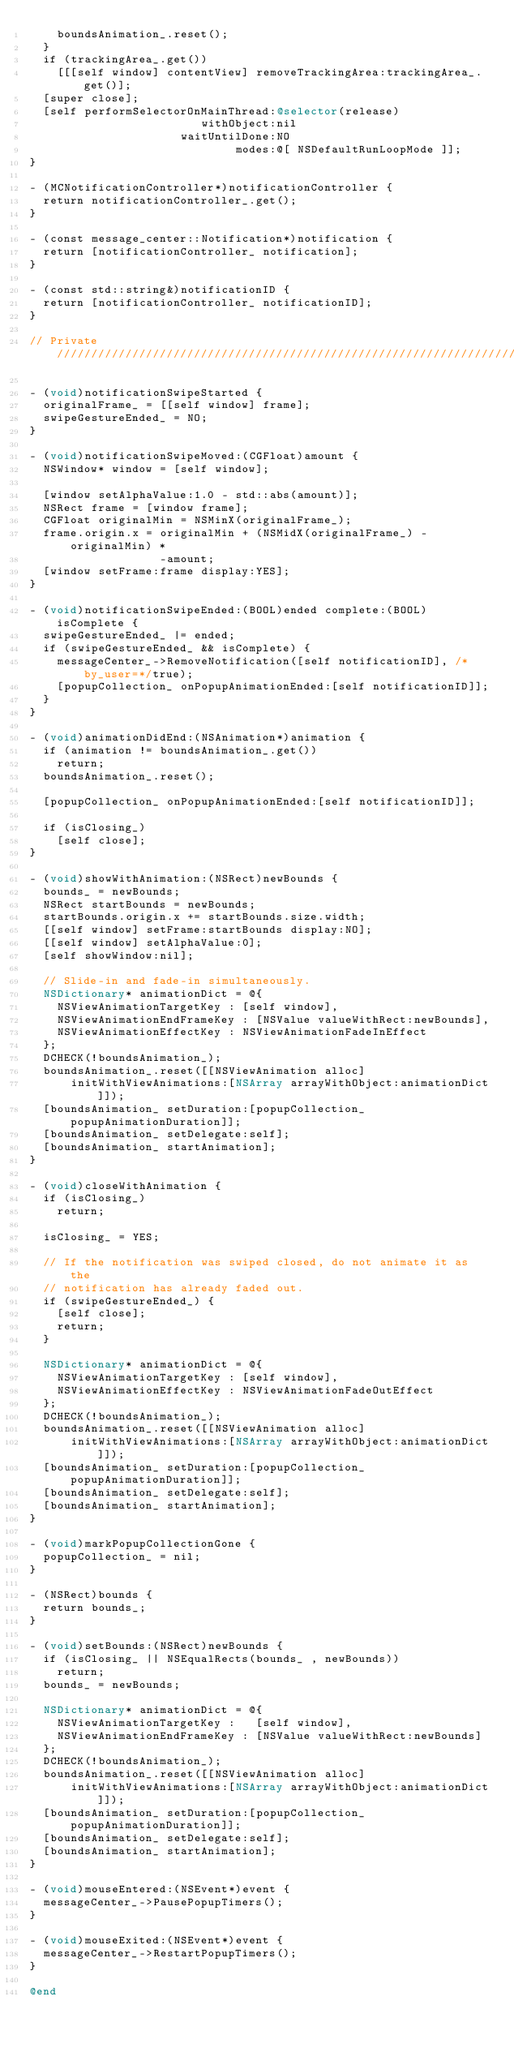Convert code to text. <code><loc_0><loc_0><loc_500><loc_500><_ObjectiveC_>    boundsAnimation_.reset();
  }
  if (trackingArea_.get())
    [[[self window] contentView] removeTrackingArea:trackingArea_.get()];
  [super close];
  [self performSelectorOnMainThread:@selector(release)
                         withObject:nil
                      waitUntilDone:NO
                              modes:@[ NSDefaultRunLoopMode ]];
}

- (MCNotificationController*)notificationController {
  return notificationController_.get();
}

- (const message_center::Notification*)notification {
  return [notificationController_ notification];
}

- (const std::string&)notificationID {
  return [notificationController_ notificationID];
}

// Private /////////////////////////////////////////////////////////////////////

- (void)notificationSwipeStarted {
  originalFrame_ = [[self window] frame];
  swipeGestureEnded_ = NO;
}

- (void)notificationSwipeMoved:(CGFloat)amount {
  NSWindow* window = [self window];

  [window setAlphaValue:1.0 - std::abs(amount)];
  NSRect frame = [window frame];
  CGFloat originalMin = NSMinX(originalFrame_);
  frame.origin.x = originalMin + (NSMidX(originalFrame_) - originalMin) *
                   -amount;
  [window setFrame:frame display:YES];
}

- (void)notificationSwipeEnded:(BOOL)ended complete:(BOOL)isComplete {
  swipeGestureEnded_ |= ended;
  if (swipeGestureEnded_ && isComplete) {
    messageCenter_->RemoveNotification([self notificationID], /*by_user=*/true);
    [popupCollection_ onPopupAnimationEnded:[self notificationID]];
  }
}

- (void)animationDidEnd:(NSAnimation*)animation {
  if (animation != boundsAnimation_.get())
    return;
  boundsAnimation_.reset();

  [popupCollection_ onPopupAnimationEnded:[self notificationID]];

  if (isClosing_)
    [self close];
}

- (void)showWithAnimation:(NSRect)newBounds {
  bounds_ = newBounds;
  NSRect startBounds = newBounds;
  startBounds.origin.x += startBounds.size.width;
  [[self window] setFrame:startBounds display:NO];
  [[self window] setAlphaValue:0];
  [self showWindow:nil];

  // Slide-in and fade-in simultaneously.
  NSDictionary* animationDict = @{
    NSViewAnimationTargetKey : [self window],
    NSViewAnimationEndFrameKey : [NSValue valueWithRect:newBounds],
    NSViewAnimationEffectKey : NSViewAnimationFadeInEffect
  };
  DCHECK(!boundsAnimation_);
  boundsAnimation_.reset([[NSViewAnimation alloc]
      initWithViewAnimations:[NSArray arrayWithObject:animationDict]]);
  [boundsAnimation_ setDuration:[popupCollection_ popupAnimationDuration]];
  [boundsAnimation_ setDelegate:self];
  [boundsAnimation_ startAnimation];
}

- (void)closeWithAnimation {
  if (isClosing_)
    return;

  isClosing_ = YES;

  // If the notification was swiped closed, do not animate it as the
  // notification has already faded out.
  if (swipeGestureEnded_) {
    [self close];
    return;
  }

  NSDictionary* animationDict = @{
    NSViewAnimationTargetKey : [self window],
    NSViewAnimationEffectKey : NSViewAnimationFadeOutEffect
  };
  DCHECK(!boundsAnimation_);
  boundsAnimation_.reset([[NSViewAnimation alloc]
      initWithViewAnimations:[NSArray arrayWithObject:animationDict]]);
  [boundsAnimation_ setDuration:[popupCollection_ popupAnimationDuration]];
  [boundsAnimation_ setDelegate:self];
  [boundsAnimation_ startAnimation];
}

- (void)markPopupCollectionGone {
  popupCollection_ = nil;
}

- (NSRect)bounds {
  return bounds_;
}

- (void)setBounds:(NSRect)newBounds {
  if (isClosing_ || NSEqualRects(bounds_ , newBounds))
    return;
  bounds_ = newBounds;

  NSDictionary* animationDict = @{
    NSViewAnimationTargetKey :   [self window],
    NSViewAnimationEndFrameKey : [NSValue valueWithRect:newBounds]
  };
  DCHECK(!boundsAnimation_);
  boundsAnimation_.reset([[NSViewAnimation alloc]
      initWithViewAnimations:[NSArray arrayWithObject:animationDict]]);
  [boundsAnimation_ setDuration:[popupCollection_ popupAnimationDuration]];
  [boundsAnimation_ setDelegate:self];
  [boundsAnimation_ startAnimation];
}

- (void)mouseEntered:(NSEvent*)event {
  messageCenter_->PausePopupTimers();
}

- (void)mouseExited:(NSEvent*)event {
  messageCenter_->RestartPopupTimers();
}

@end
</code> 